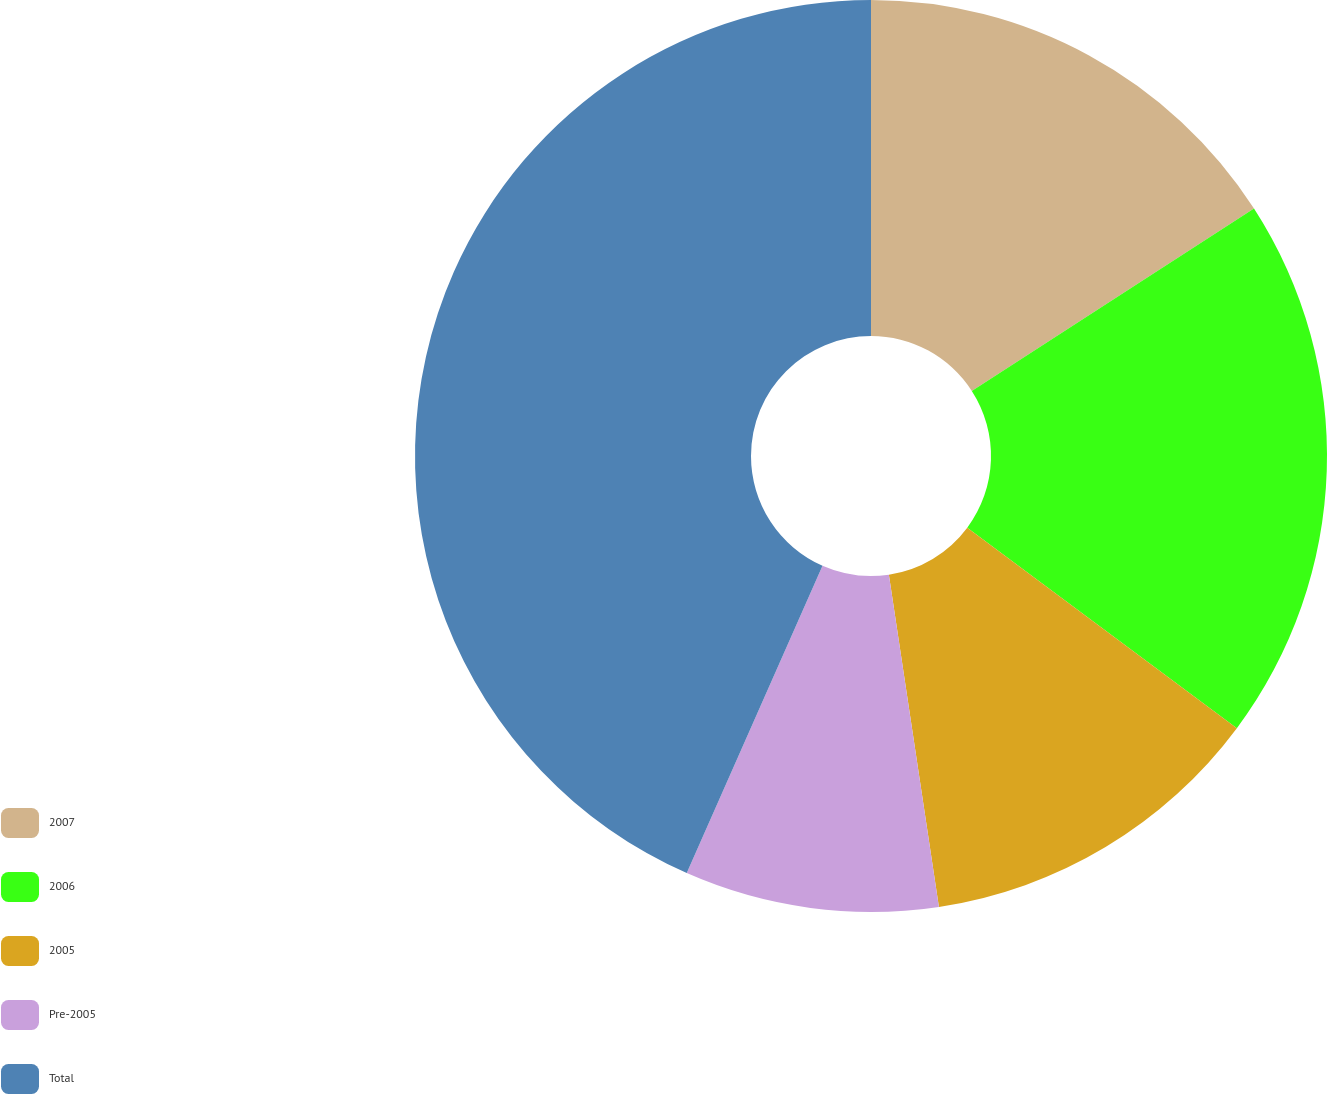Convert chart. <chart><loc_0><loc_0><loc_500><loc_500><pie_chart><fcel>2007<fcel>2006<fcel>2005<fcel>Pre-2005<fcel>Total<nl><fcel>15.87%<fcel>19.31%<fcel>12.44%<fcel>9.0%<fcel>43.38%<nl></chart> 